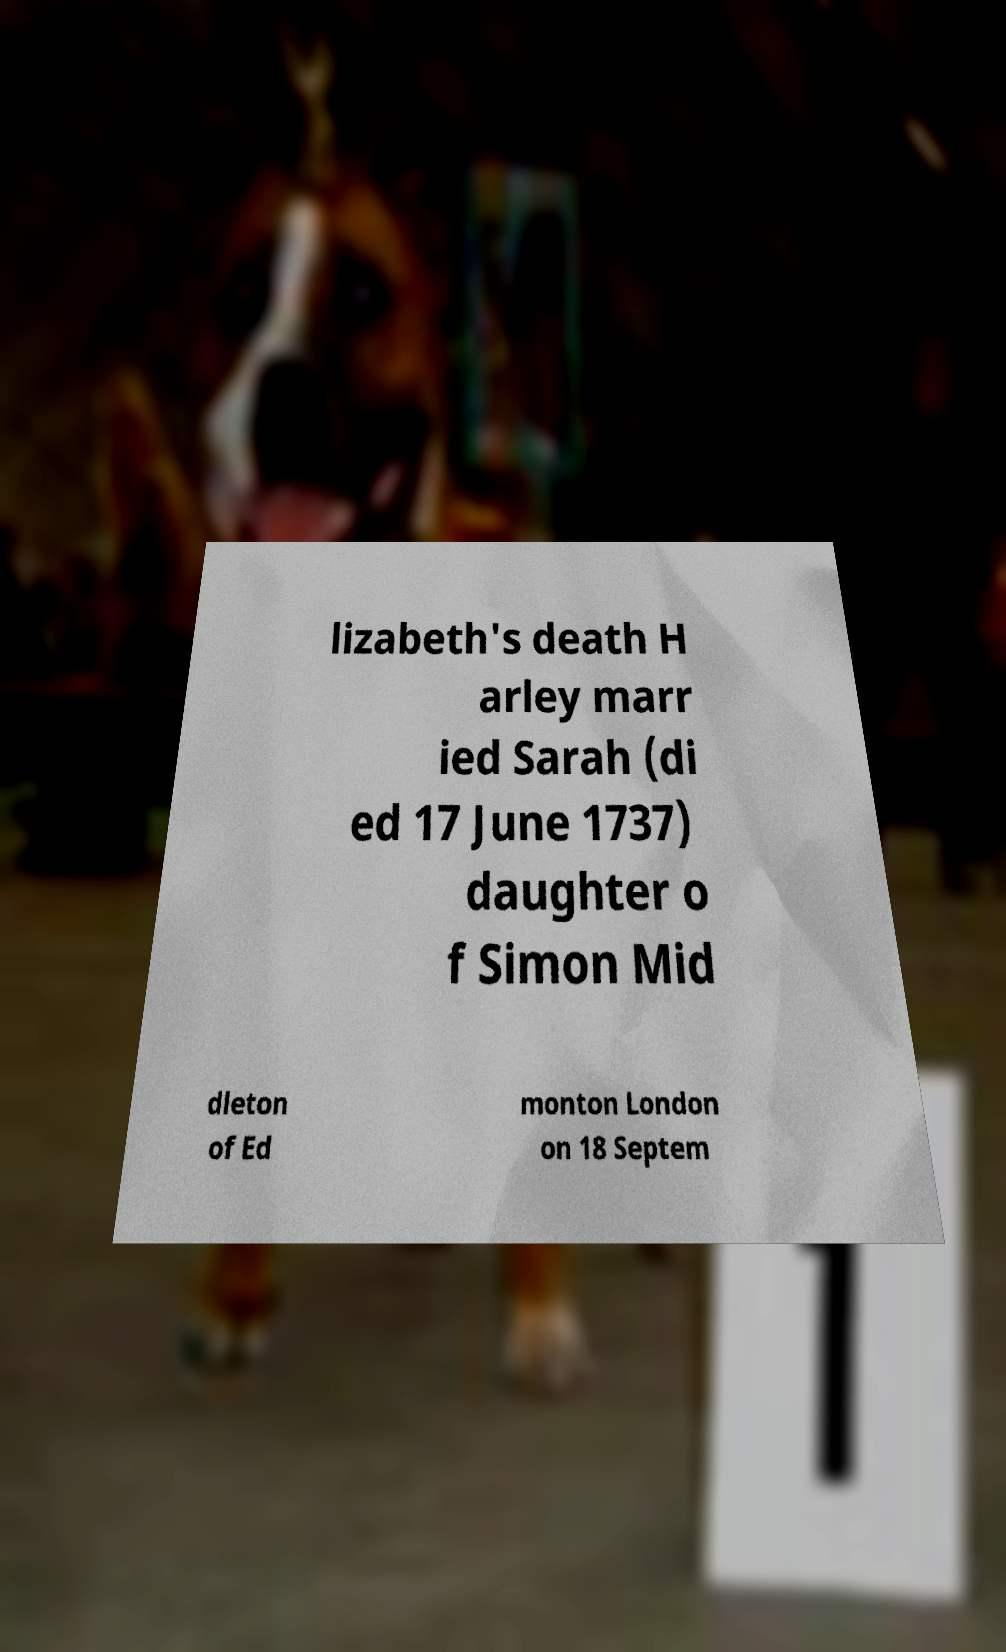Could you extract and type out the text from this image? lizabeth's death H arley marr ied Sarah (di ed 17 June 1737) daughter o f Simon Mid dleton of Ed monton London on 18 Septem 